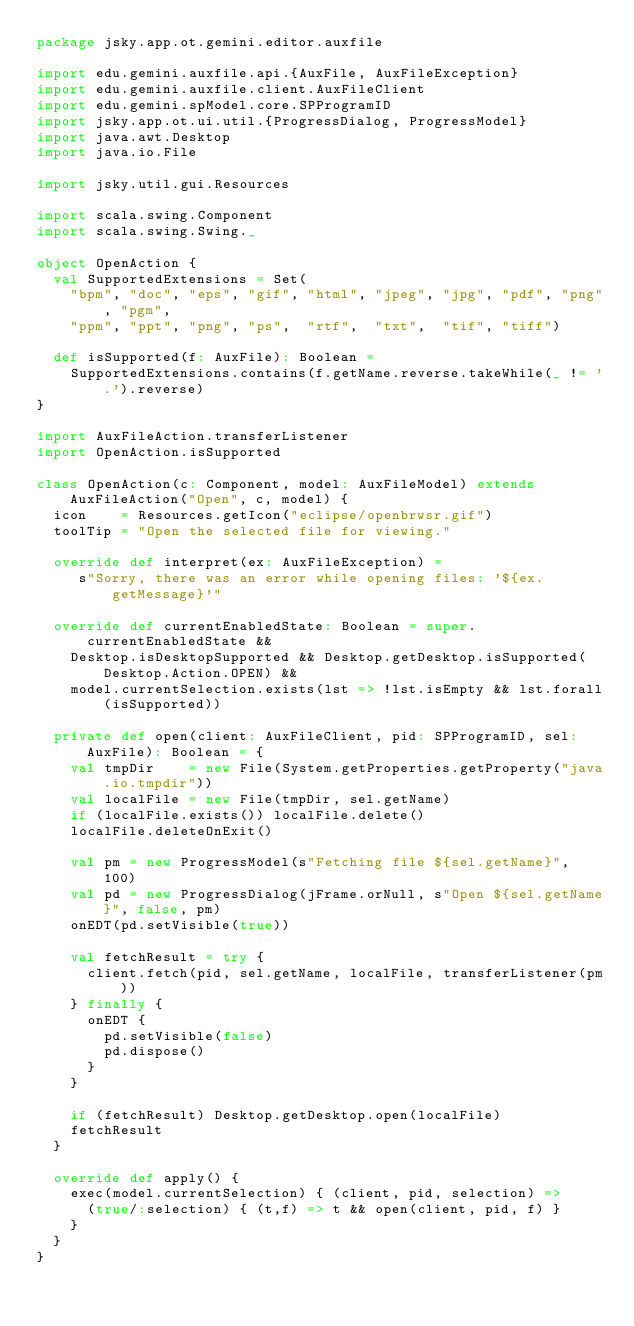<code> <loc_0><loc_0><loc_500><loc_500><_Scala_>package jsky.app.ot.gemini.editor.auxfile

import edu.gemini.auxfile.api.{AuxFile, AuxFileException}
import edu.gemini.auxfile.client.AuxFileClient
import edu.gemini.spModel.core.SPProgramID
import jsky.app.ot.ui.util.{ProgressDialog, ProgressModel}
import java.awt.Desktop
import java.io.File

import jsky.util.gui.Resources

import scala.swing.Component
import scala.swing.Swing._

object OpenAction {
  val SupportedExtensions = Set(
    "bpm", "doc", "eps", "gif", "html", "jpeg", "jpg", "pdf", "png", "pgm",
    "ppm", "ppt", "png", "ps",  "rtf",  "txt",  "tif", "tiff")

  def isSupported(f: AuxFile): Boolean =
    SupportedExtensions.contains(f.getName.reverse.takeWhile(_ != '.').reverse)
}

import AuxFileAction.transferListener
import OpenAction.isSupported

class OpenAction(c: Component, model: AuxFileModel) extends AuxFileAction("Open", c, model) {
  icon    = Resources.getIcon("eclipse/openbrwsr.gif")
  toolTip = "Open the selected file for viewing."

  override def interpret(ex: AuxFileException) =
     s"Sorry, there was an error while opening files: '${ex.getMessage}'"

  override def currentEnabledState: Boolean = super.currentEnabledState &&
    Desktop.isDesktopSupported && Desktop.getDesktop.isSupported(Desktop.Action.OPEN) &&
    model.currentSelection.exists(lst => !lst.isEmpty && lst.forall(isSupported))

  private def open(client: AuxFileClient, pid: SPProgramID, sel: AuxFile): Boolean = {
    val tmpDir    = new File(System.getProperties.getProperty("java.io.tmpdir"))
    val localFile = new File(tmpDir, sel.getName)
    if (localFile.exists()) localFile.delete()
    localFile.deleteOnExit()

    val pm = new ProgressModel(s"Fetching file ${sel.getName}", 100)
    val pd = new ProgressDialog(jFrame.orNull, s"Open ${sel.getName}", false, pm)
    onEDT(pd.setVisible(true))

    val fetchResult = try {
      client.fetch(pid, sel.getName, localFile, transferListener(pm))
    } finally {
      onEDT {
        pd.setVisible(false)
        pd.dispose()
      }
    }

    if (fetchResult) Desktop.getDesktop.open(localFile)
    fetchResult
  }

  override def apply() {
    exec(model.currentSelection) { (client, pid, selection) =>
      (true/:selection) { (t,f) => t && open(client, pid, f) }
    }
  }
}
</code> 